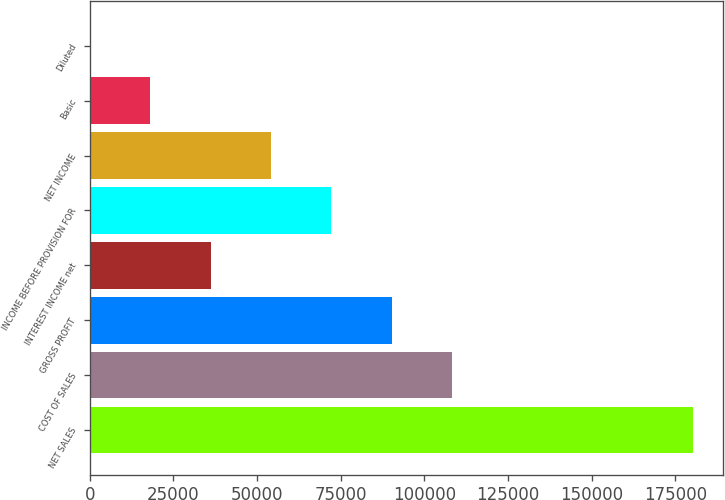Convert chart. <chart><loc_0><loc_0><loc_500><loc_500><bar_chart><fcel>NET SALES<fcel>COST OF SALES<fcel>GROSS PROFIT<fcel>INTEREST INCOME net<fcel>INCOME BEFORE PROVISION FOR<fcel>NET INCOME<fcel>Basic<fcel>Diluted<nl><fcel>180341<fcel>108205<fcel>90170.6<fcel>36068.4<fcel>72136.5<fcel>54102.5<fcel>18034.3<fcel>0.22<nl></chart> 